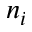<formula> <loc_0><loc_0><loc_500><loc_500>n _ { i }</formula> 